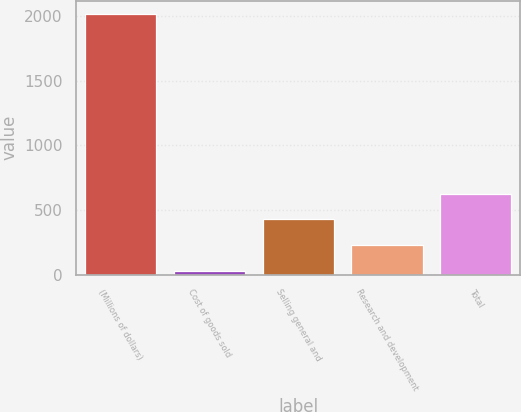Convert chart. <chart><loc_0><loc_0><loc_500><loc_500><bar_chart><fcel>(Millions of dollars)<fcel>Cost of goods sold<fcel>Selling general and<fcel>Research and development<fcel>Total<nl><fcel>2017<fcel>29<fcel>426.6<fcel>227.8<fcel>625.4<nl></chart> 